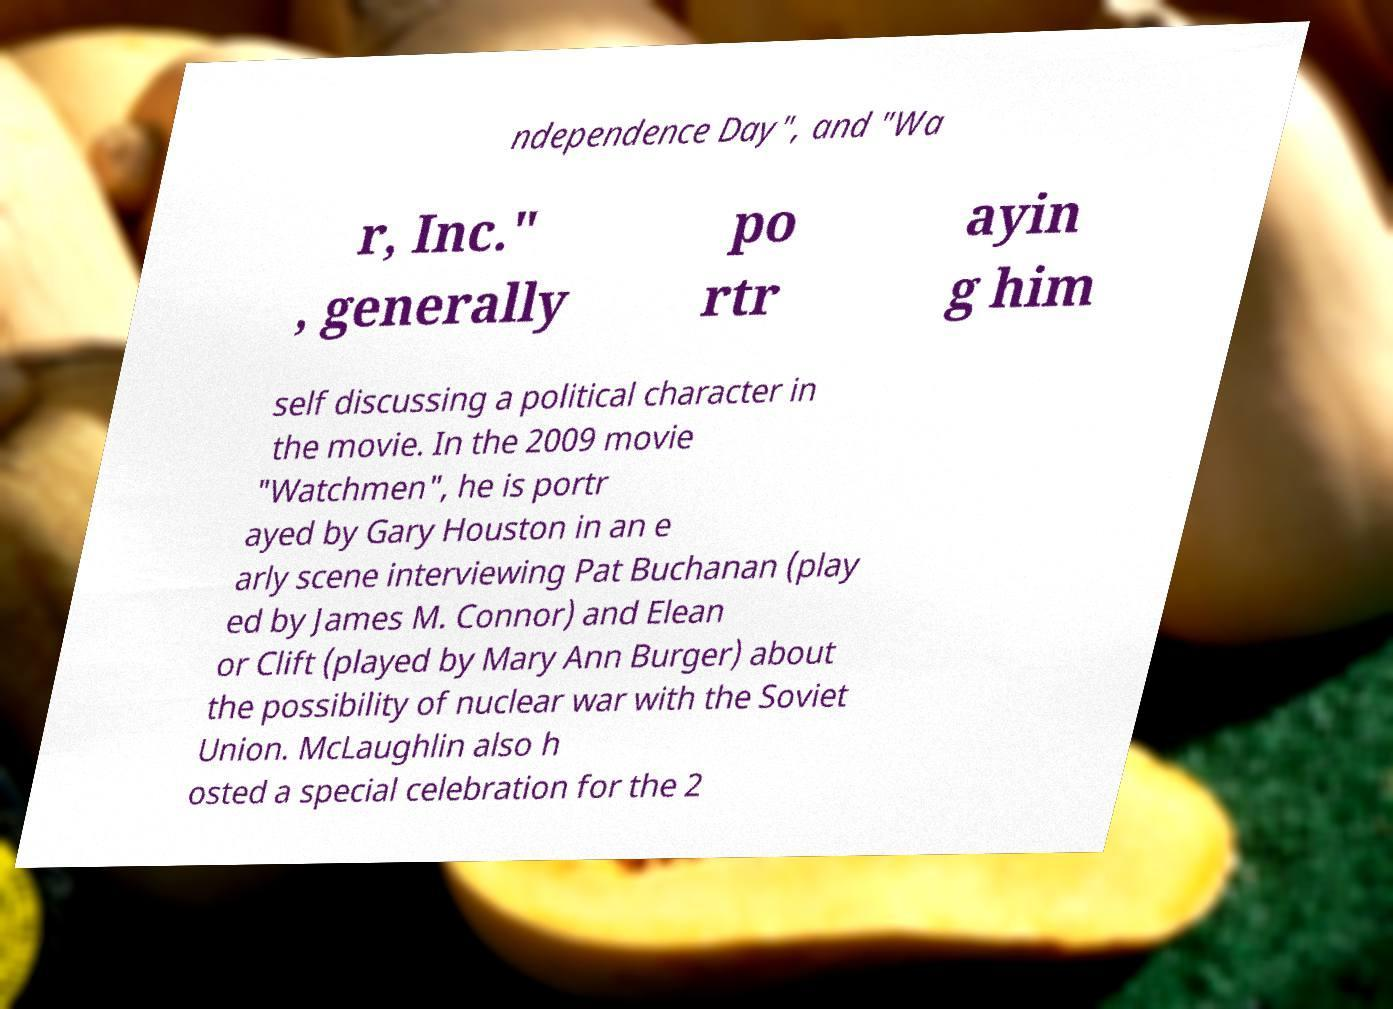For documentation purposes, I need the text within this image transcribed. Could you provide that? ndependence Day", and "Wa r, Inc." , generally po rtr ayin g him self discussing a political character in the movie. In the 2009 movie "Watchmen", he is portr ayed by Gary Houston in an e arly scene interviewing Pat Buchanan (play ed by James M. Connor) and Elean or Clift (played by Mary Ann Burger) about the possibility of nuclear war with the Soviet Union. McLaughlin also h osted a special celebration for the 2 